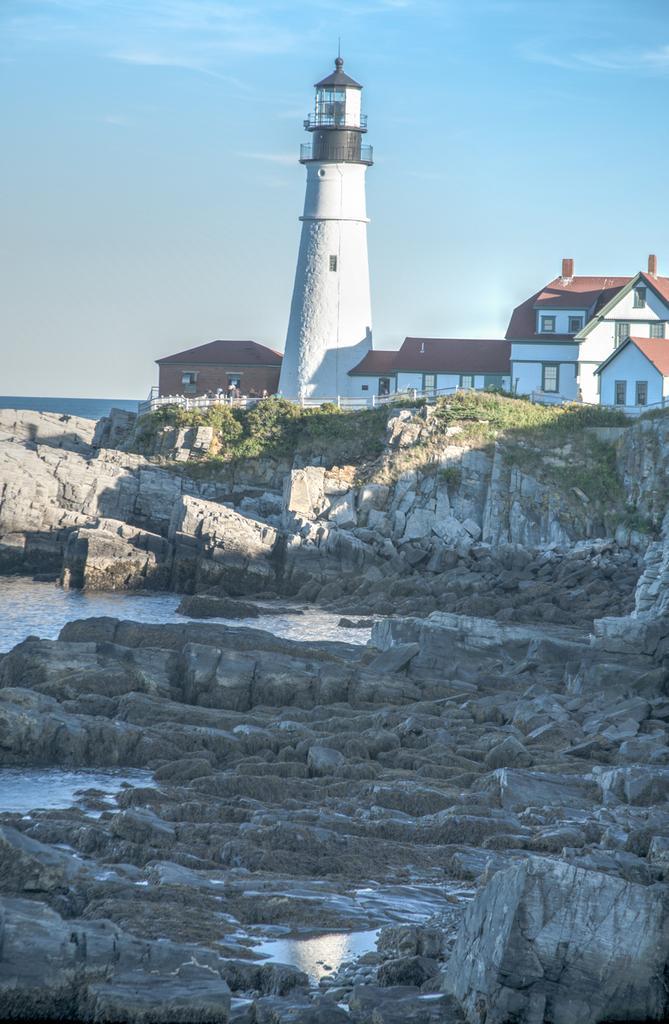How would you summarize this image in a sentence or two? In this picture we can see rocks, water, grass, plants, railing, houses and light house. In the background of the image we can see the sky. 